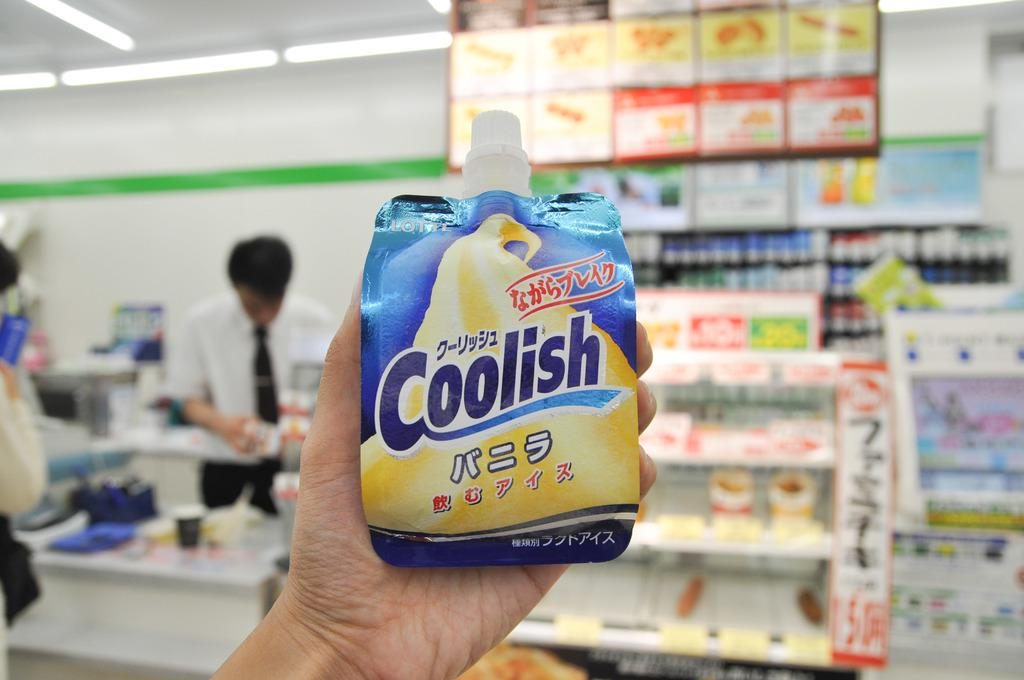<image>
Present a compact description of the photo's key features. Someone holding up a packaged product called Coolish 